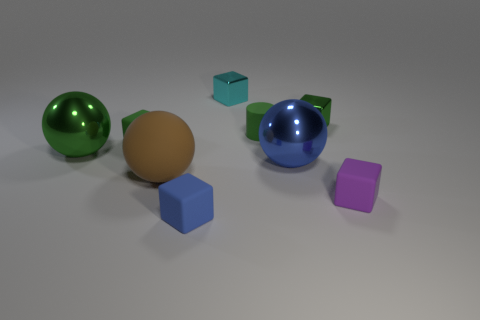There is a block on the left side of the big rubber sphere; is its color the same as the rubber cylinder?
Provide a succinct answer. Yes. Do the tiny matte thing left of the big brown rubber object and the large ball on the left side of the brown ball have the same color?
Make the answer very short. Yes. Are there any blue matte cubes on the right side of the brown matte thing?
Provide a succinct answer. Yes. What number of tiny purple things have the same shape as the cyan thing?
Offer a very short reply. 1. There is a metal sphere that is to the right of the green rubber thing right of the green cube on the left side of the small blue cube; what color is it?
Offer a terse response. Blue. Is the material of the tiny block in front of the purple rubber thing the same as the tiny purple cube on the right side of the large brown ball?
Provide a short and direct response. Yes. What number of things are either tiny green blocks left of the blue matte object or big yellow things?
Provide a succinct answer. 1. How many things are purple matte spheres or large balls to the left of the cyan object?
Keep it short and to the point. 2. How many brown matte things are the same size as the green metal sphere?
Offer a very short reply. 1. Is the number of green matte things in front of the small purple object less than the number of tiny cyan metallic objects that are left of the small green rubber block?
Your answer should be compact. No. 